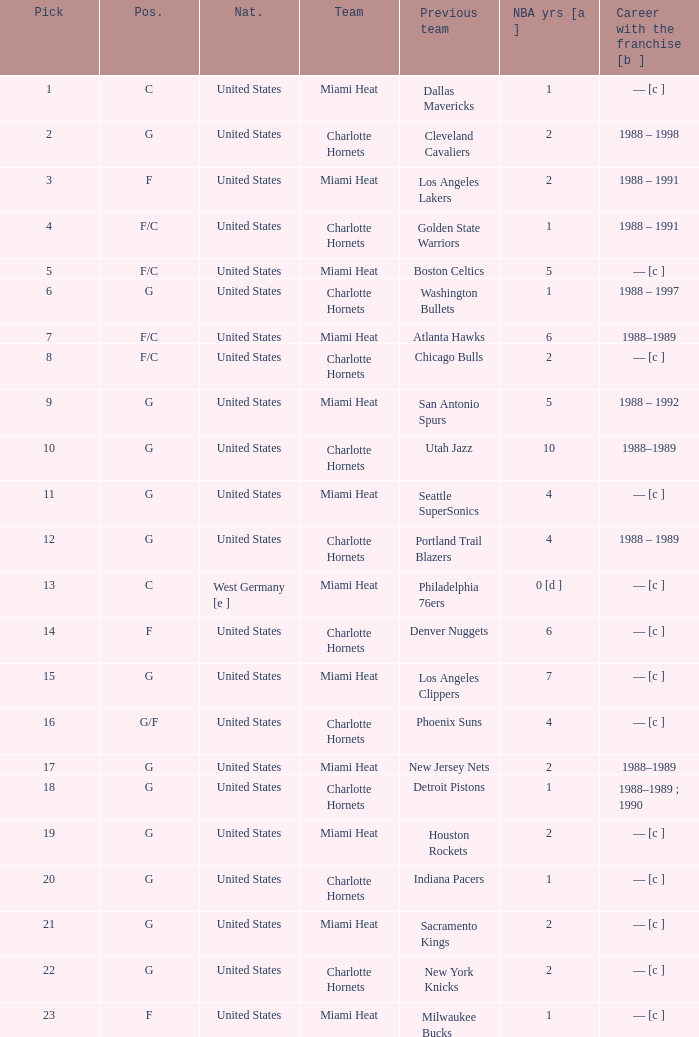What is the team of the player who was previously on the indiana pacers? Charlotte Hornets. 